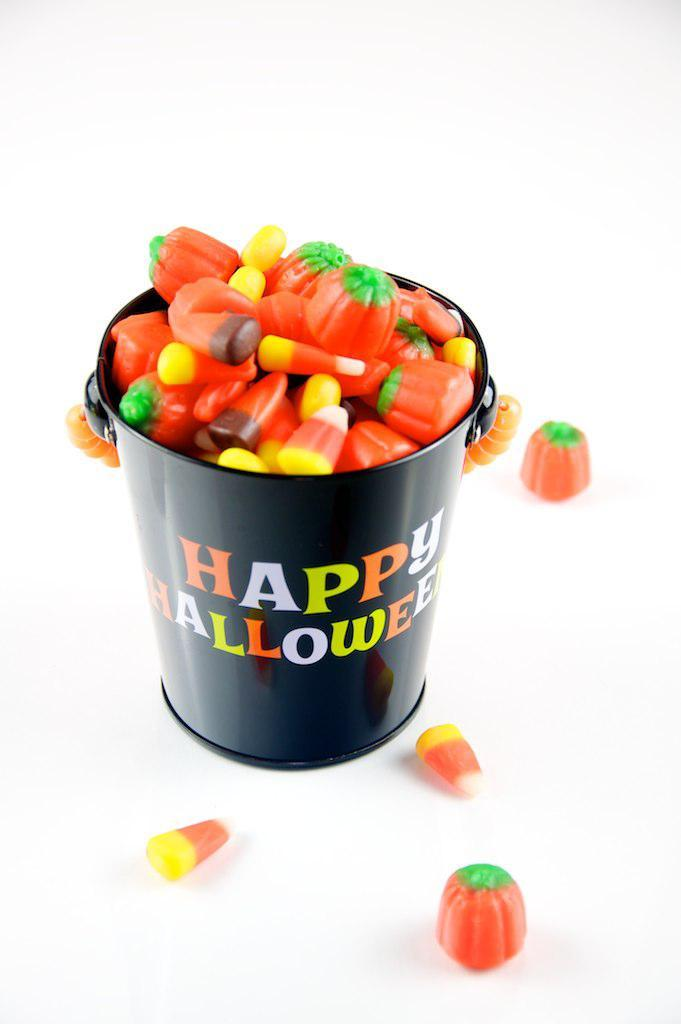What objects are present in the image? There are toys in the image. Where are the toys located? The toys are in a bucket. Can you describe the position of the bucket in the image? The bucket is in the center of the image. What type of stamp can be seen on the toys in the image? There is no stamp present on the toys in the image. What instrument is being played by the toys in the image? There are no instruments or people playing instruments in the image; it only features toys in a bucket. 